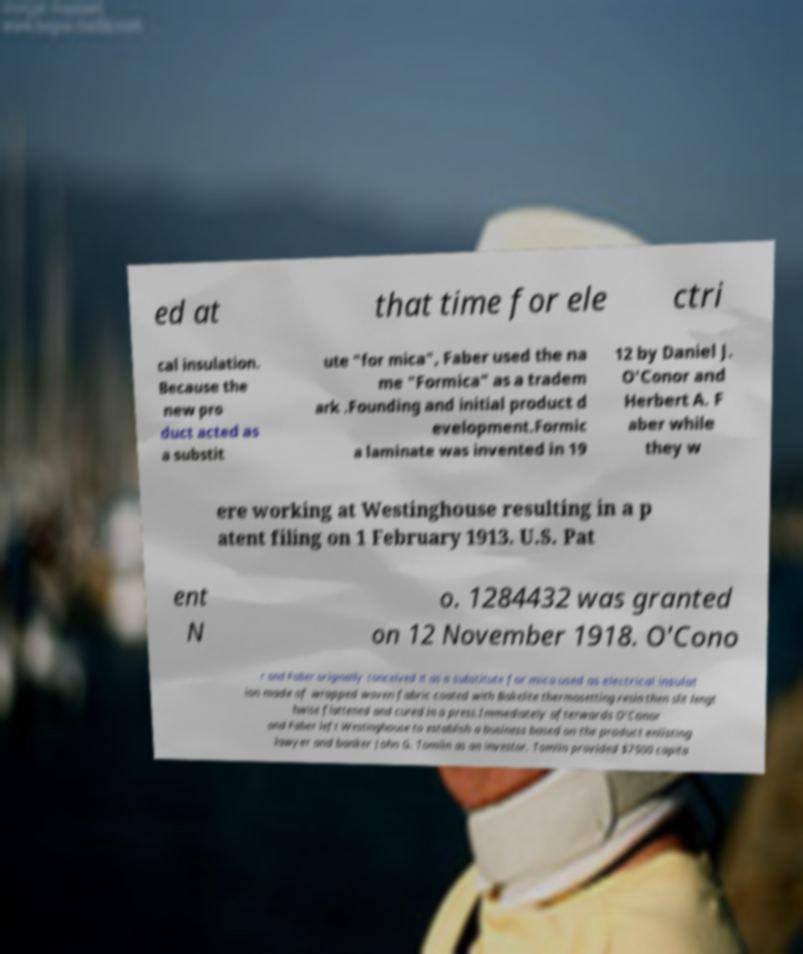Please identify and transcribe the text found in this image. ed at that time for ele ctri cal insulation. Because the new pro duct acted as a substit ute "for mica", Faber used the na me "Formica" as a tradem ark .Founding and initial product d evelopment.Formic a laminate was invented in 19 12 by Daniel J. O'Conor and Herbert A. F aber while they w ere working at Westinghouse resulting in a p atent filing on 1 February 1913. U.S. Pat ent N o. 1284432 was granted on 12 November 1918. O'Cono r and Faber originally conceived it as a substitute for mica used as electrical insulat ion made of wrapped woven fabric coated with Bakelite thermosetting resin then slit lengt hwise flattened and cured in a press.Immediately afterwards O'Conor and Faber left Westinghouse to establish a business based on the product enlisting lawyer and banker John G. Tomlin as an investor. Tomlin provided $7500 capita 